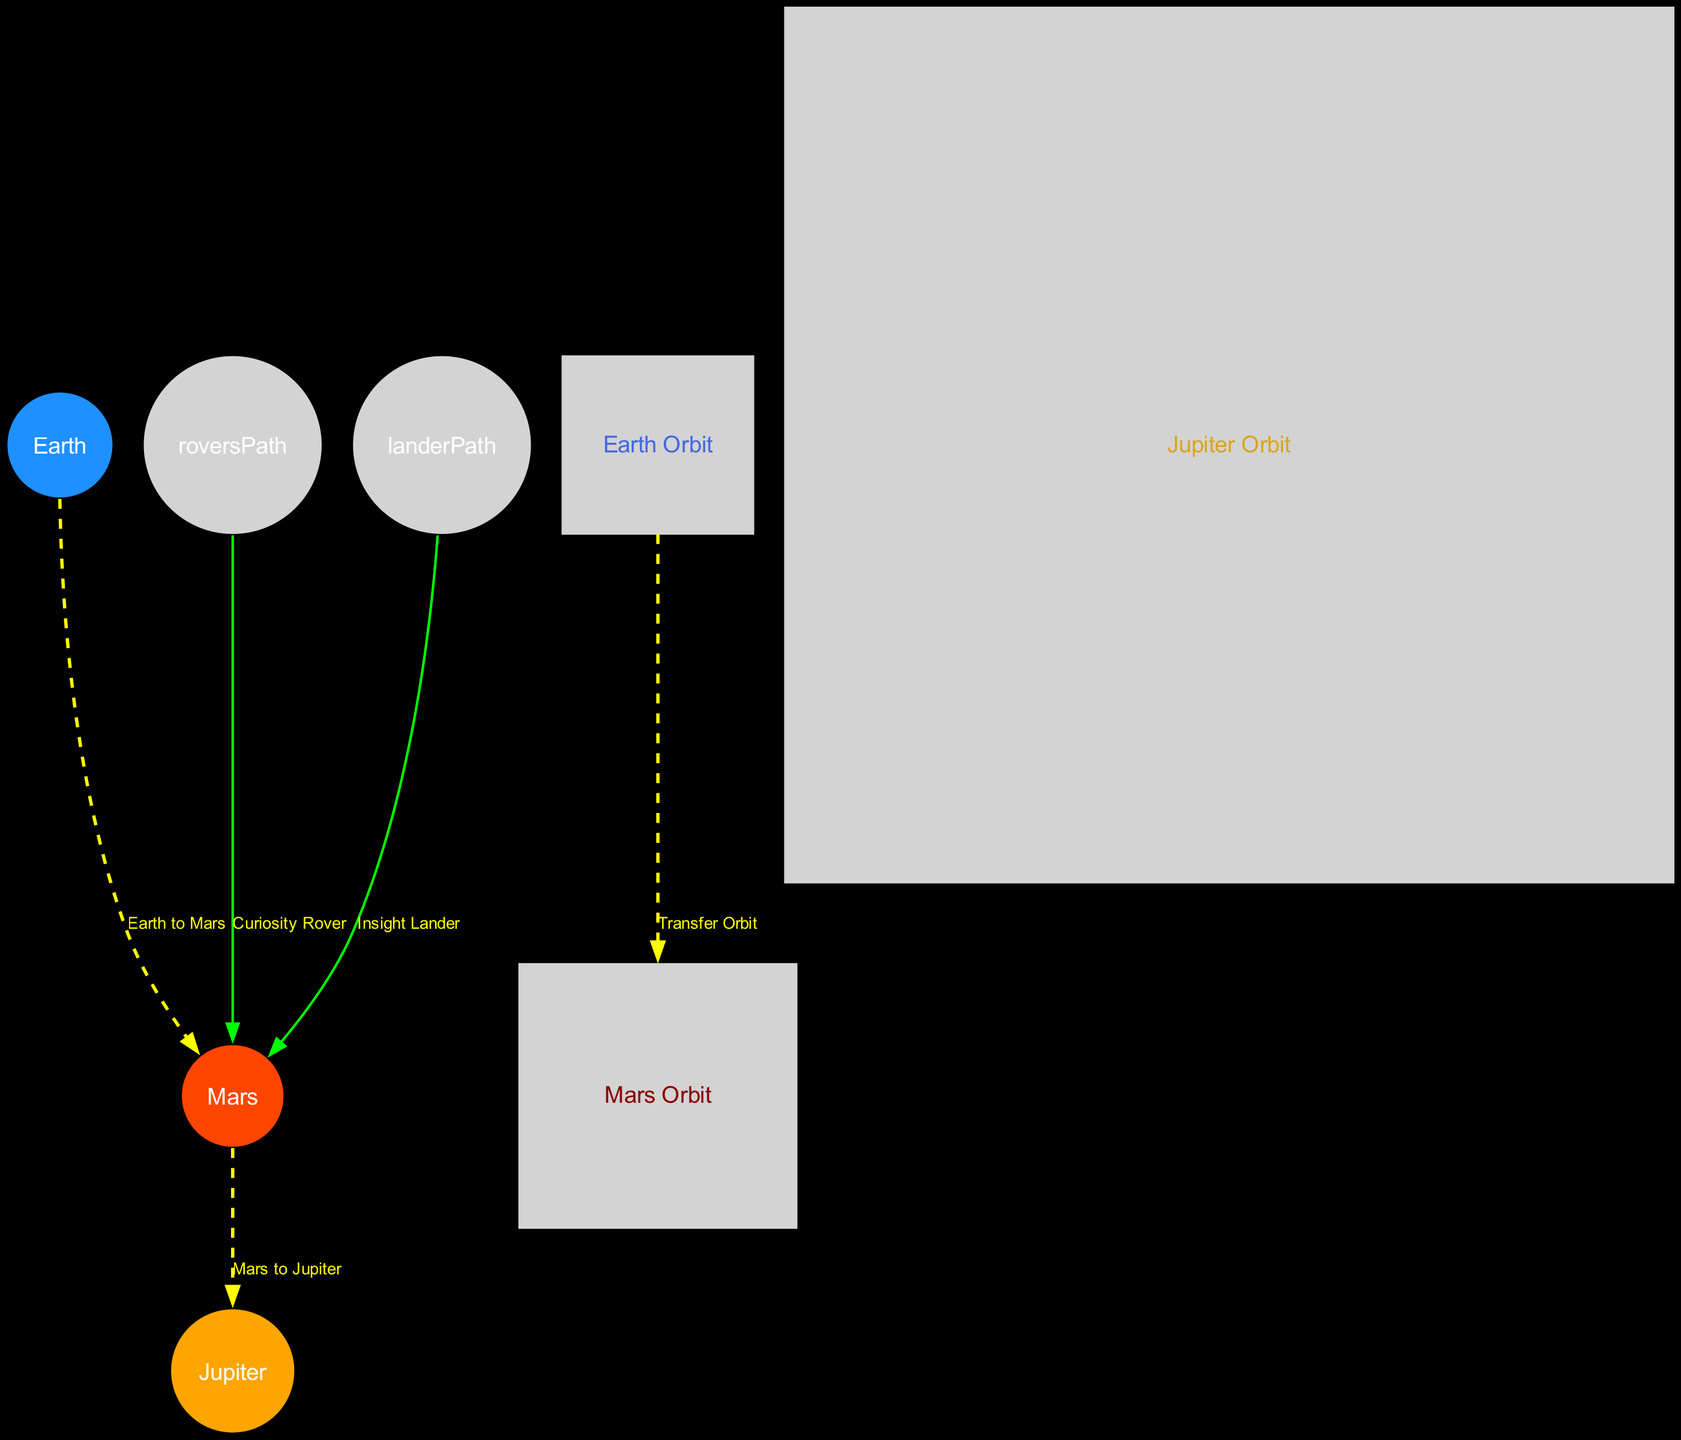What is the distance from Earth to Mars? The labels on the direct trajectory from Earth to Mars do not specify a numerical distance, but the position values for Earth and Mars show that Mars is located at coordinates (1.5, 0.75). To calculate the distance, we can use the coordinates: distance = sqrt((1.5 - 0)^2 + (0.75 - 0)^2) which equals approximately 1.58 units.
Answer: 1.58 units How many planets are represented in the diagram? The nodes listed in the diagram include Earth, Mars, and Jupiter, which are identified as planets. By counting these specific entries, we find that there are three planets represented.
Answer: 3 What color is Mars depicted in the diagram? The color scheme for the planets indicates that Mars is represented by the color #FF4500. This information can be found within the designated planet_colors dictionary where each planet's hex color is defined.
Answer: Red Which trajectory connects Mars and Jupiter? The edge labeled "Mars to Jupiter" directly connects the nodes labeled Mars and Jupiter. By examining the edges in the data, this connection is clear and distinctly marked in the diagram.
Answer: Mars to Jupiter What is the label of the orbit associated with Earth? By looking at the node designated as "earthOrbit", the label specifically states "Earth Orbit". This detail can be directly found in the nodes array under Earth's orbit.
Answer: Earth Orbit What is the purpose of the Curiosity Rover path? The Curiosity Rover path is defined as an exploration path that leads to Mars, indicated by the edge connecting "roversPath" to "mars". This label explicitly states its purpose, showcasing the connection for robotic exploration.
Answer: Exploration How many edges are connected to Mars? The edges related to Mars include those to Earth, Jupiter, the Curiosity Rover, and the Insight Lander. By analyzing and counting the edges that involve the Mars node, we can determine a total of four connections.
Answer: 4 What is the radius of the Jupiter Orbit? The radius of Jupiter Orbit can be found in the respective orbit node, where it is explicitly defined as 5.2. This numerical value directly relates to the orbit designated for Jupiter.
Answer: 5.2 What type of paths are shown in the diagram? The diagram includes exploration paths, specifically labeled as "Curiosity Rover Path" and "Insight Lander Path". Both of these are categorized under the type "path" in the structure of connections.
Answer: Exploration paths 